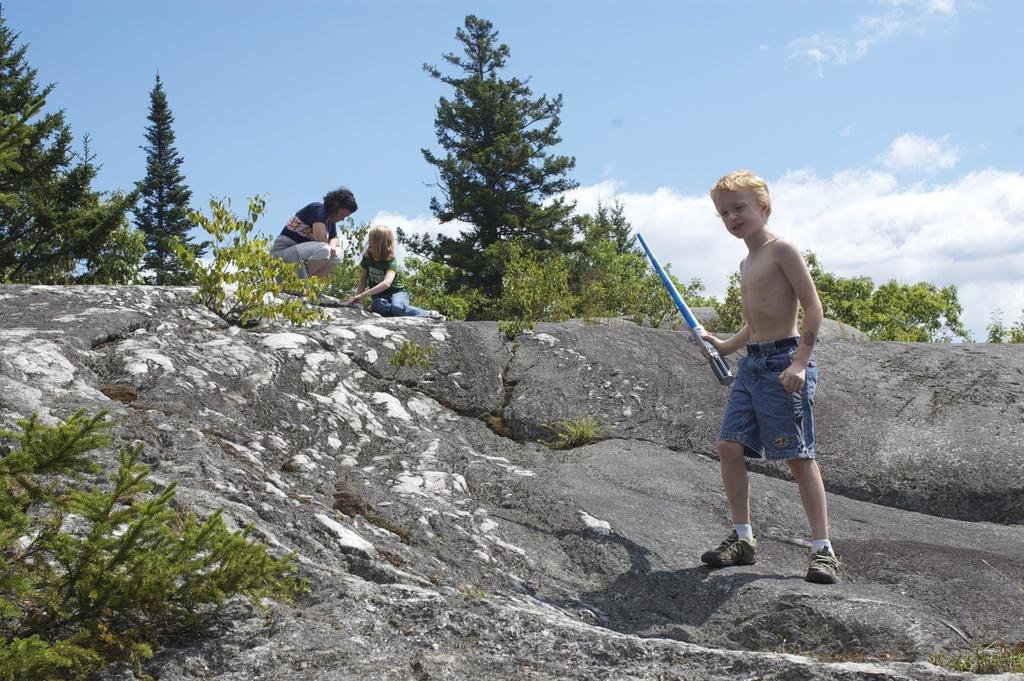Who is present in the image? There is a woman and two kids in the image. What is one of the kids holding in his hand? One of the kids is holding a stick in his hand. Where is the kid holding the stick standing? The kid holding the stick is standing on a rock. What can be seen in the background of the image? There are trees and the sky visible in the background of the image. What color is the horse in the image? There is no horse present in the image. What type of dinosaur can be seen in the background of the image? There are no dinosaurs present in the image; only trees and the sky are visible in the background. 